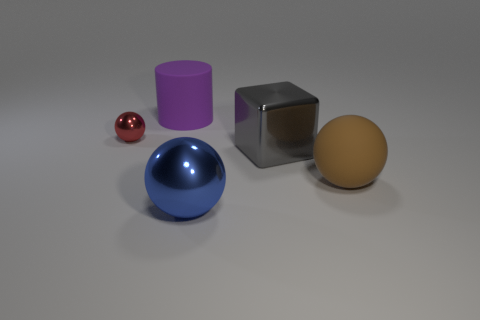Add 4 tiny yellow cylinders. How many objects exist? 9 Subtract all cubes. How many objects are left? 4 Add 2 small metal spheres. How many small metal spheres are left? 3 Add 5 rubber cylinders. How many rubber cylinders exist? 6 Subtract 0 yellow balls. How many objects are left? 5 Subtract all big cubes. Subtract all tiny purple metal things. How many objects are left? 4 